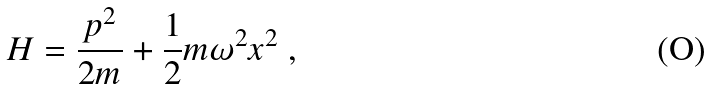Convert formula to latex. <formula><loc_0><loc_0><loc_500><loc_500>H = \frac { p ^ { 2 } } { 2 m } + \frac { 1 } { 2 } m \omega ^ { 2 } x ^ { 2 } \ ,</formula> 